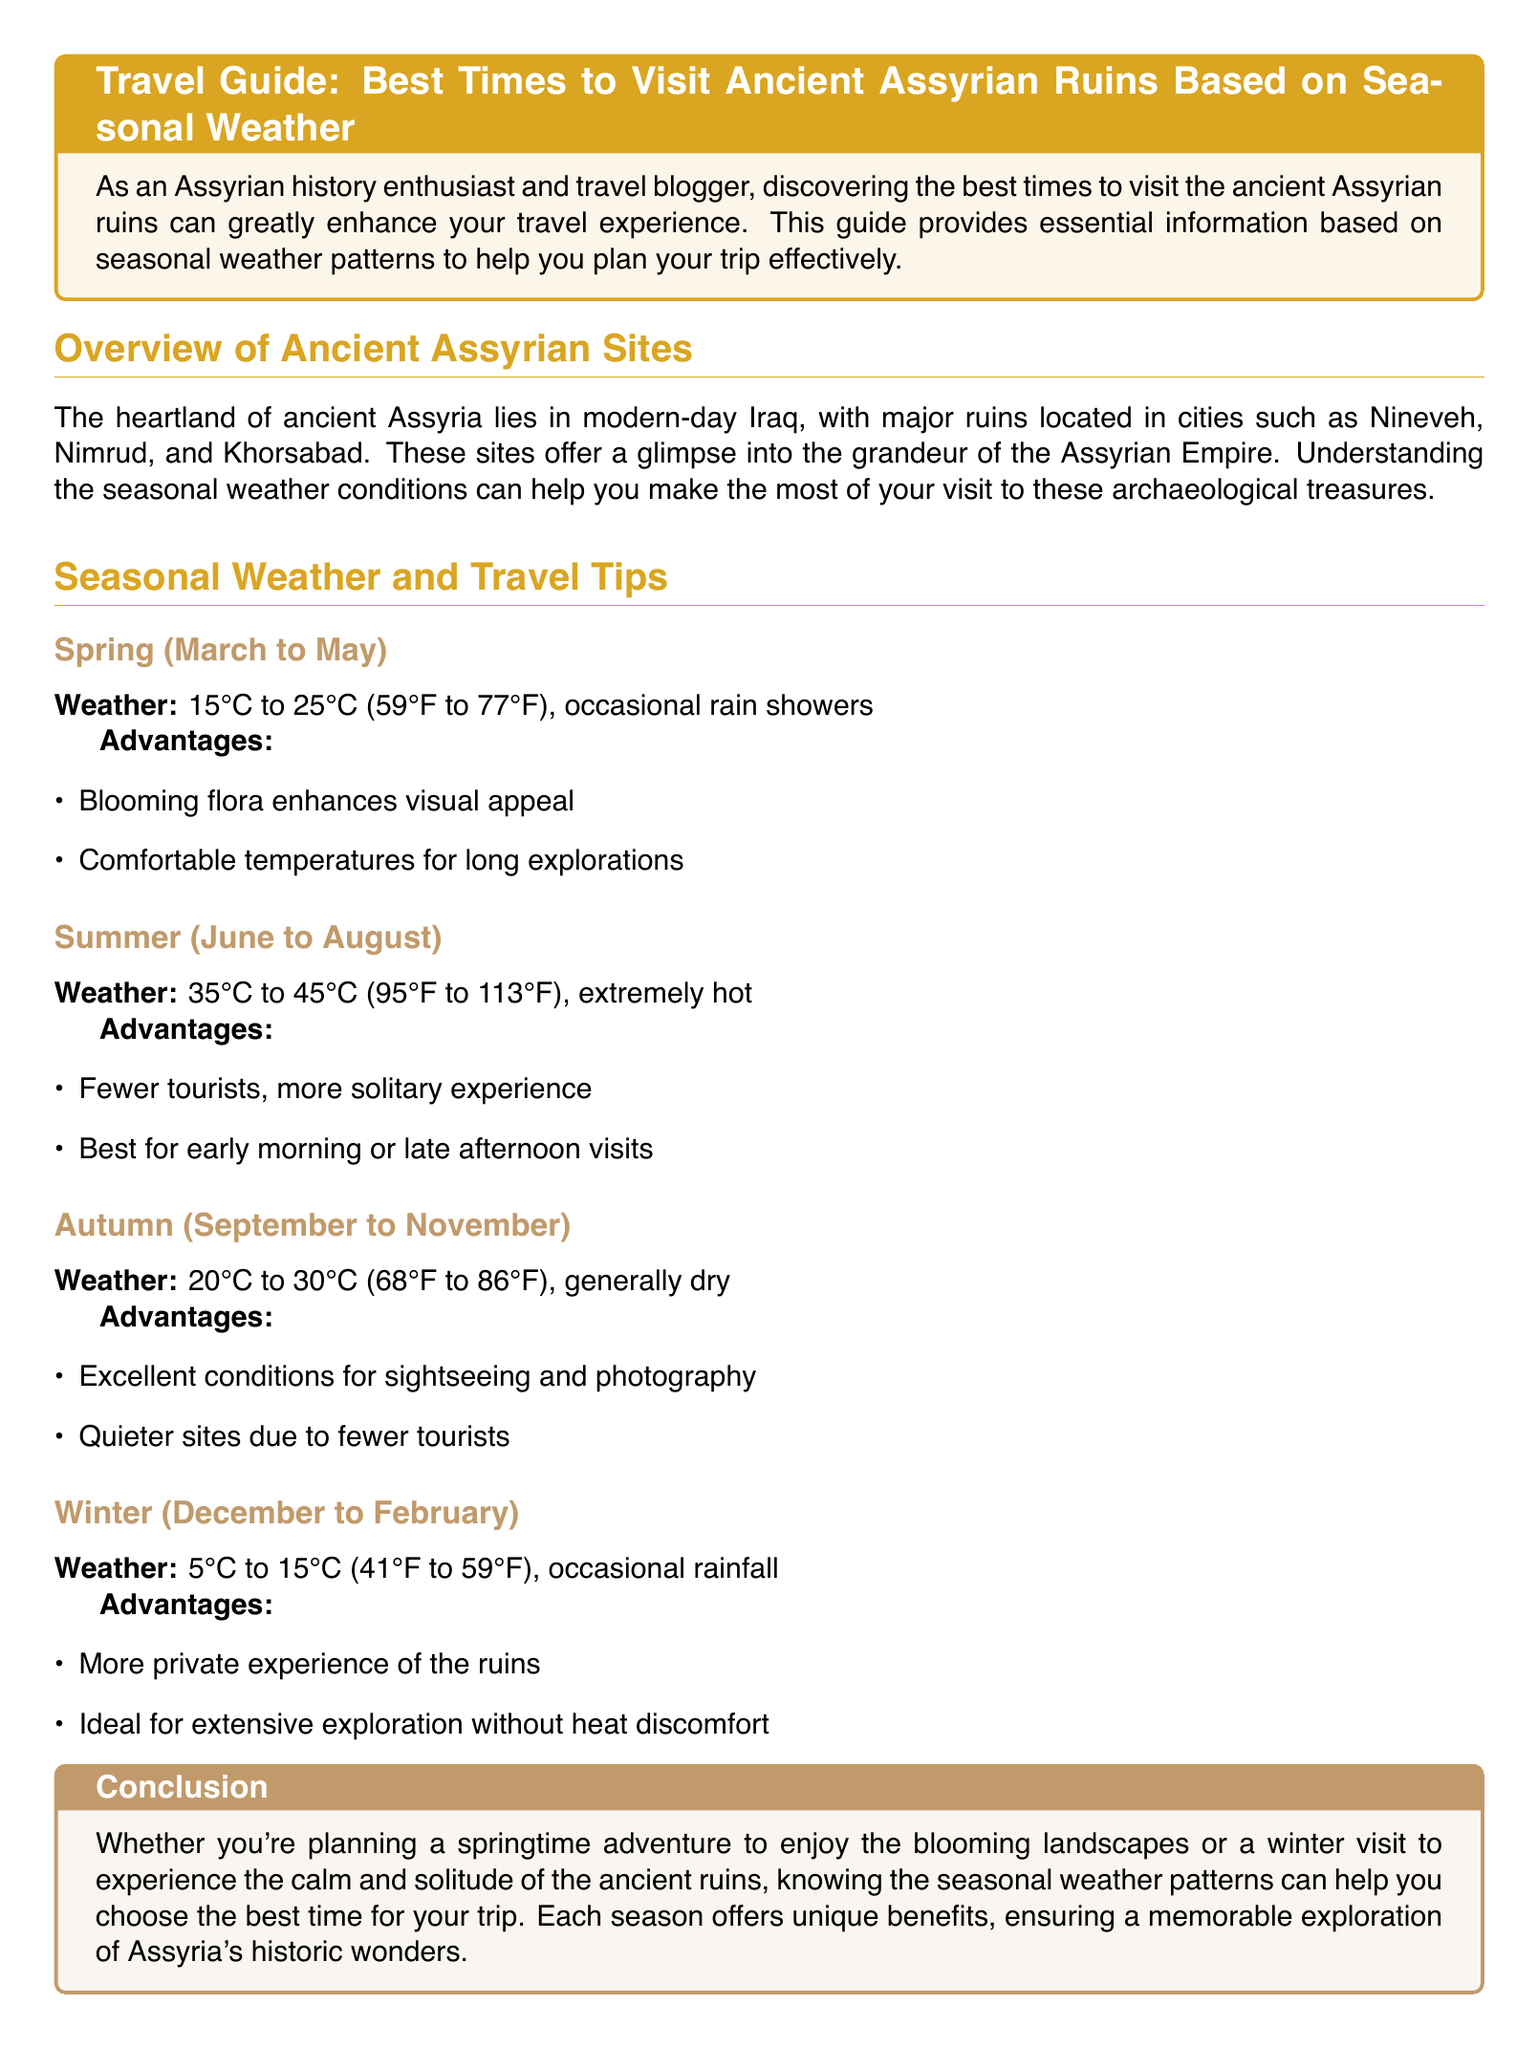What is the temperature range in spring? The temperature range in spring is indicated as 15°C to 25°C (59°F to 77°F) in the document.
Answer: 15°C to 25°C What months define summer in the document? The document states that summer is from June to August.
Answer: June to August What is an advantage of visiting in summer? It mentions that fewer tourists result in a more solitary experience during summer visits.
Answer: Fewer tourists What is the winter temperature range? The winter temperature range is mentioned as 5°C to 15°C (41°F to 59°F).
Answer: 5°C to 15°C What season is recommended for blooming flora? The document identifies spring as the season when blooming flora enhances visual appeal.
Answer: Spring What is a benefit of autumn visits according to the document? The document notes that autumn provides excellent conditions for sightseeing and photography.
Answer: Excellent conditions for sightseeing What is a key feature of winter visits to Assyrian ruins? The document indicates that winter allows for a more private experience of the ruins.
Answer: More private experience What is the recommended time for summer visits? It is suggested that early morning or late afternoon are the best times for summer visits.
Answer: Early morning or late afternoon What temperature is associated with autumn? The document states that autumn temperatures range from 20°C to 30°C (68°F to 86°F).
Answer: 20°C to 30°C 